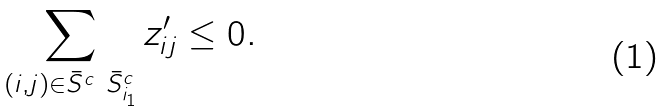Convert formula to latex. <formula><loc_0><loc_0><loc_500><loc_500>\sum _ { ( i , j ) \in \bar { S } ^ { c } \ \bar { S } ^ { c } _ { i _ { 1 } } } z ^ { \prime } _ { i j } \leq 0 .</formula> 